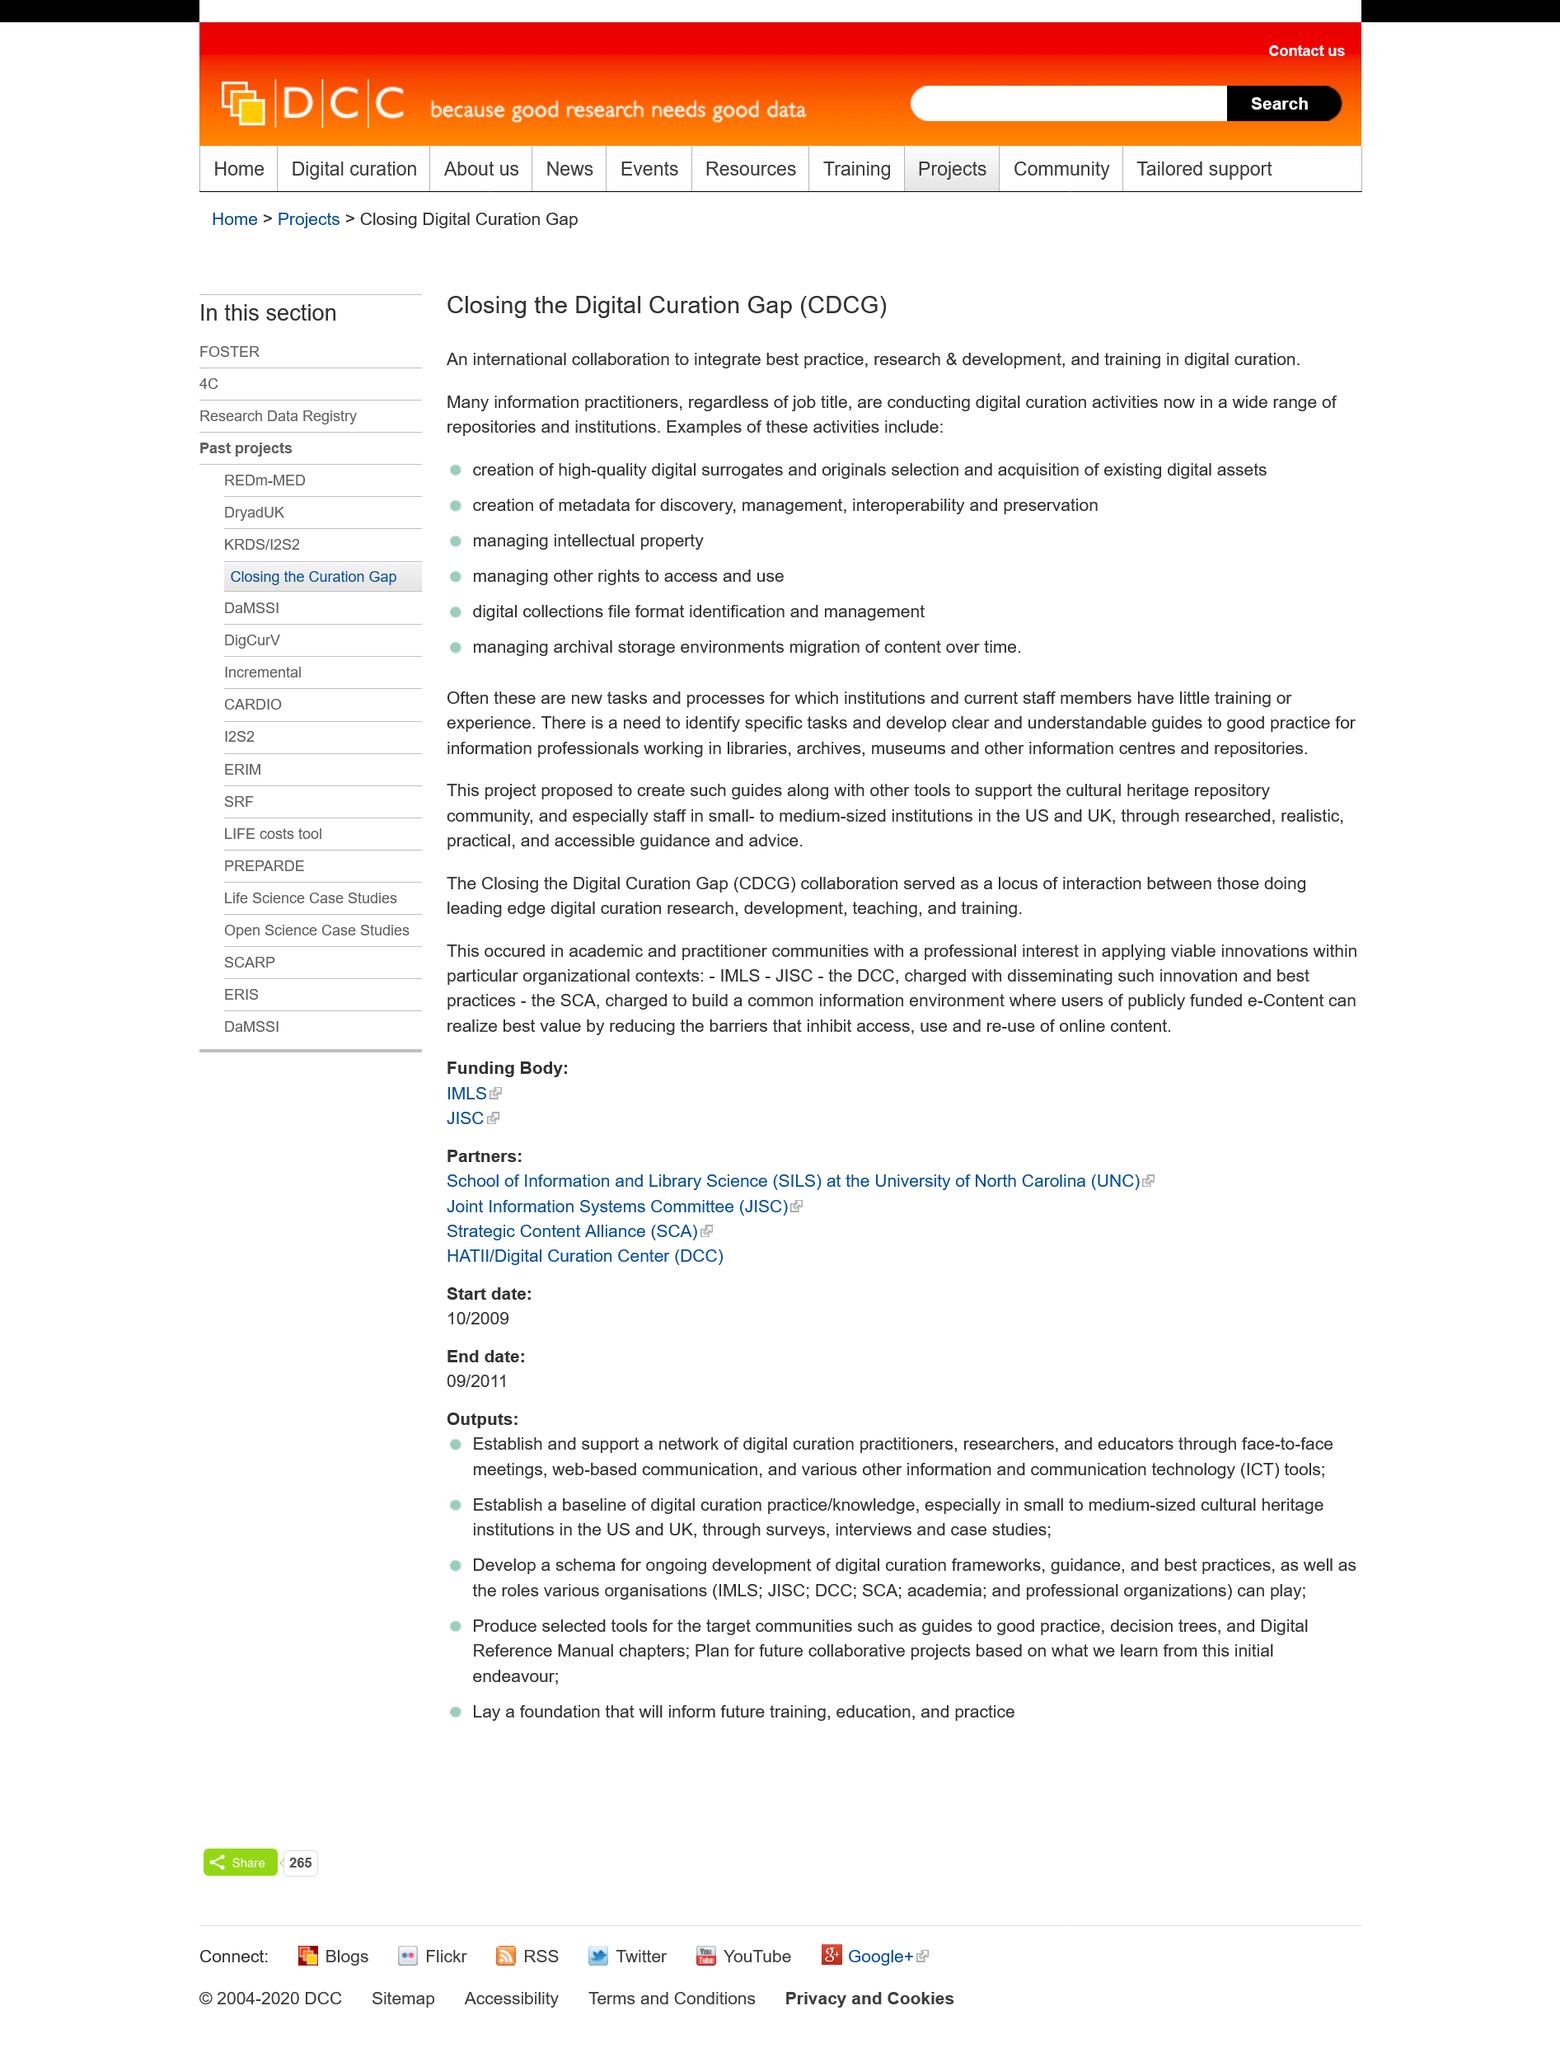List a handful of essential elements in this visual. Managing intellectual property is an example of a digital curation activity, as it involves the preservation and management of digital assets for long-term access and use. Closing the Digital Curation Gap" is an acronym that stands for "CDCG. This collaboration is a transnational endeavor, encompassing multiple countries and nationalities. 